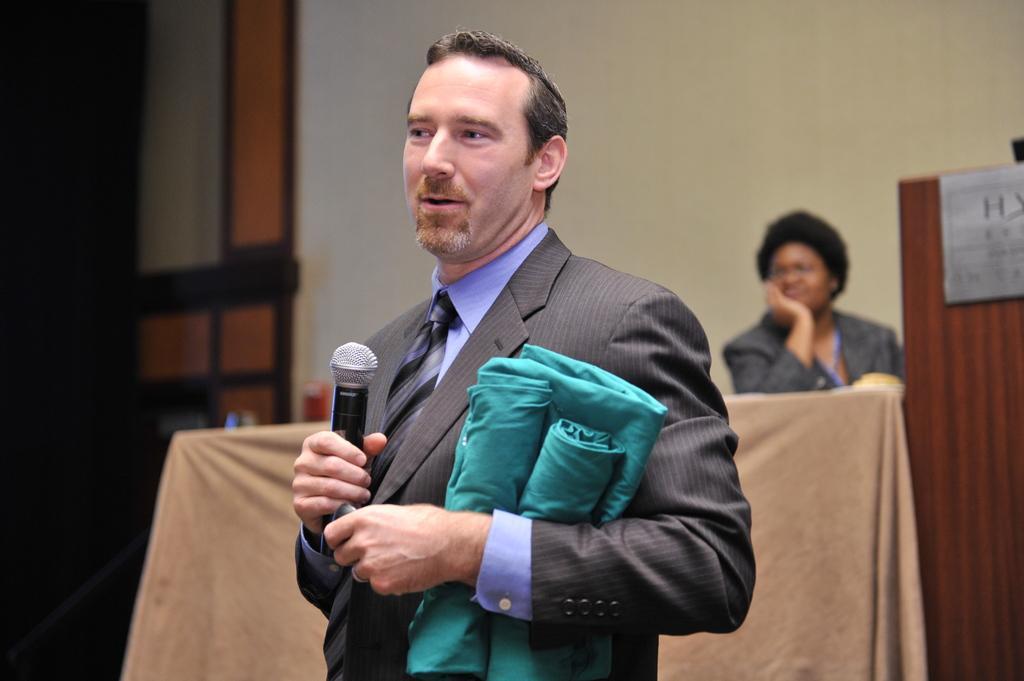Can you describe this image briefly? In this picture a guy is talking with a mic in his hand and holding a blue color cloth in his another hand. In the background we observe a lady sitting on a brown table. 